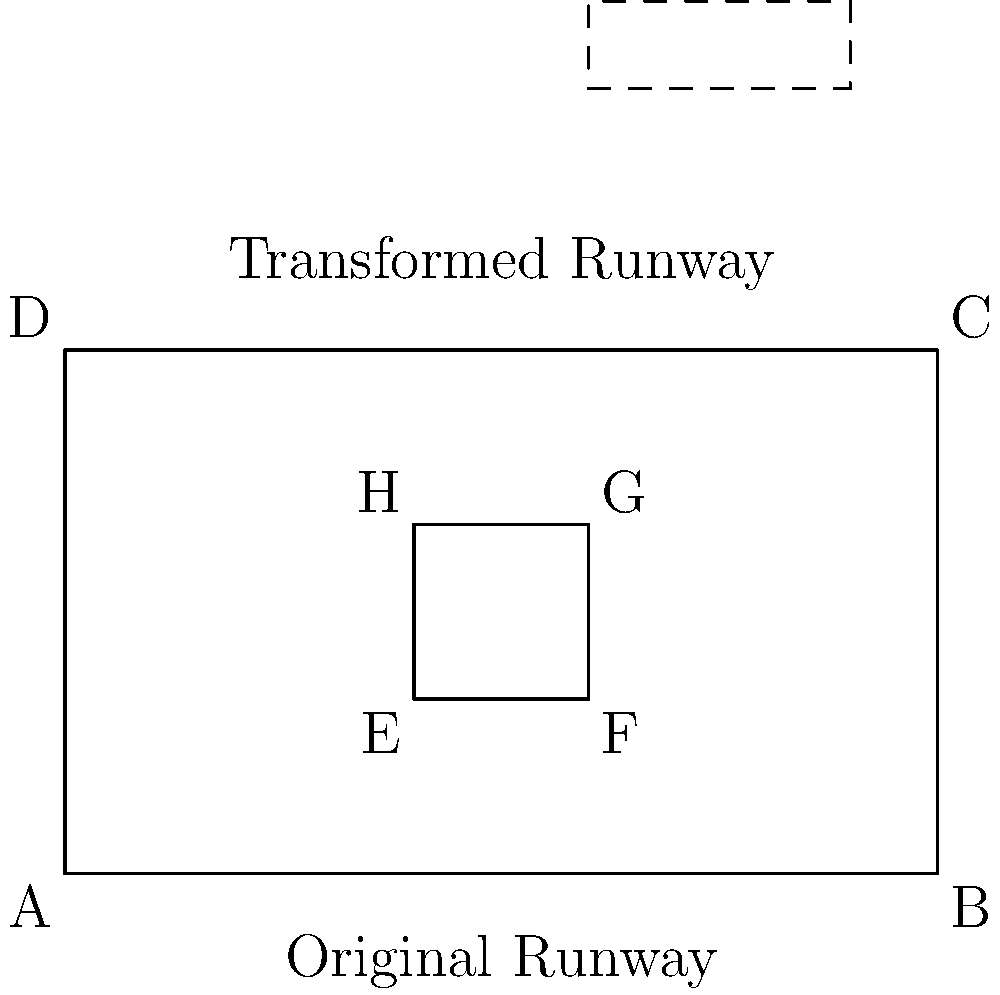An airport runway system, represented by rectangle EFGH, undergoes a composite transformation. It is first translated 4 units upward, then dilated by a factor of 1.5 horizontally and 0.5 vertically. If the original runway's dimensions are 1 unit by 1 unit, what is the area of the transformed runway in square units? Let's approach this step-by-step:

1) The original runway EFGH has dimensions 1 unit by 1 unit, so its initial area is 1 square unit.

2) The first transformation is a translation 4 units upward. This doesn't change the shape or size of the runway, only its position.

3) The second transformation is a dilation:
   - Horizontally by a factor of 1.5
   - Vertically by a factor of 0.5

4) To find the new dimensions:
   - New width = 1 * 1.5 = 1.5 units
   - New height = 1 * 0.5 = 0.5 units

5) The area of the transformed runway is:
   $A = \text{width} * \text{height} = 1.5 * 0.5 = 0.75$ square units

Therefore, the area of the transformed runway is 0.75 square units.
Answer: 0.75 square units 